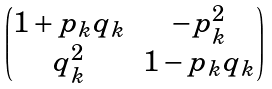<formula> <loc_0><loc_0><loc_500><loc_500>\begin{pmatrix} 1 + p _ { k } q _ { k } & - p _ { k } ^ { 2 } \\ q _ { k } ^ { 2 } & 1 - p _ { k } q _ { k } \end{pmatrix}</formula> 